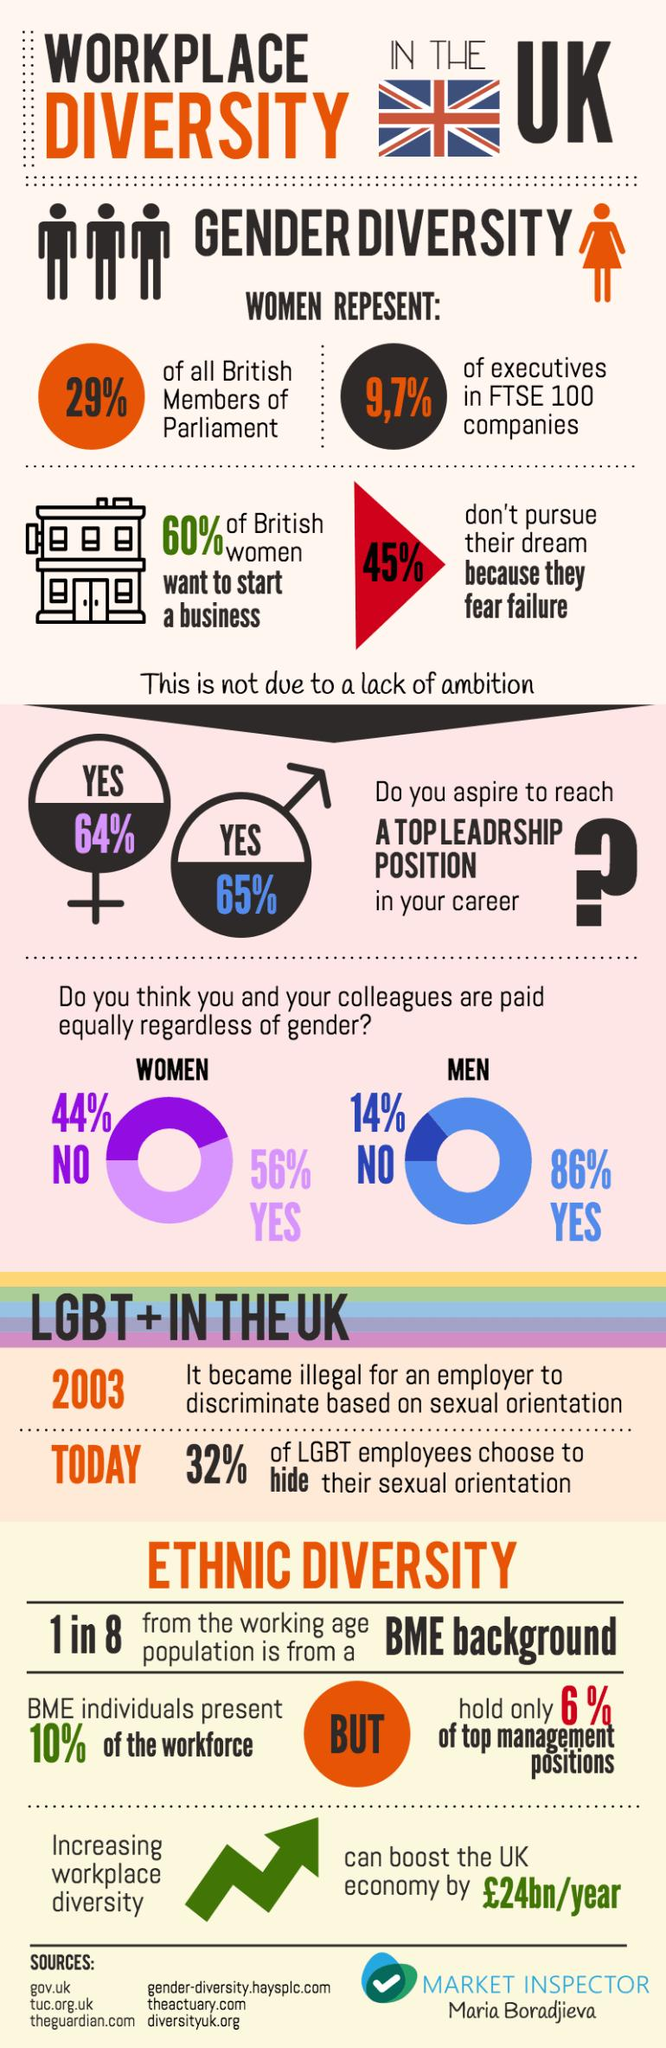Indicate a few pertinent items in this graphic. According to the survey, only 6% of BME individuals hold top management positions in the UK. According to a survey, 68% of LGBT employees in the UK do not choose to hide their sexual orientation. According to a survey in the UK, 64% of women aspire to reach a top leadership position in their career. According to a survey in the UK, 65% of men aspire to reach a top leadership position in their career. According to a survey in the UK, 86% of men believe that they are paid equally regardless of their gender. 